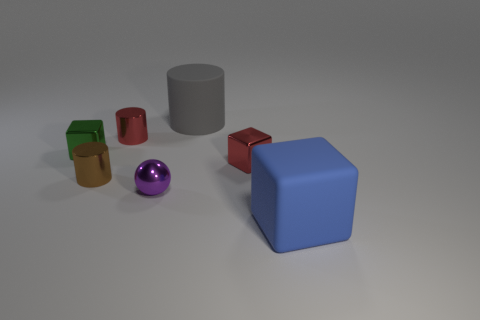Subtract all red metallic cylinders. How many cylinders are left? 2 Add 1 large objects. How many objects exist? 8 Subtract 1 cubes. How many cubes are left? 2 Subtract all cubes. How many objects are left? 4 Add 2 green cubes. How many green cubes are left? 3 Add 4 tiny blue cylinders. How many tiny blue cylinders exist? 4 Subtract 1 red cylinders. How many objects are left? 6 Subtract all green cubes. Subtract all red balls. How many cubes are left? 2 Subtract all large gray objects. Subtract all blue rubber blocks. How many objects are left? 5 